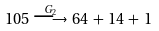<formula> <loc_0><loc_0><loc_500><loc_500>1 0 5 \, \stackrel { G _ { 2 } } { \longrightarrow } \, 6 4 \, + \, 1 4 \, + \, 1</formula> 